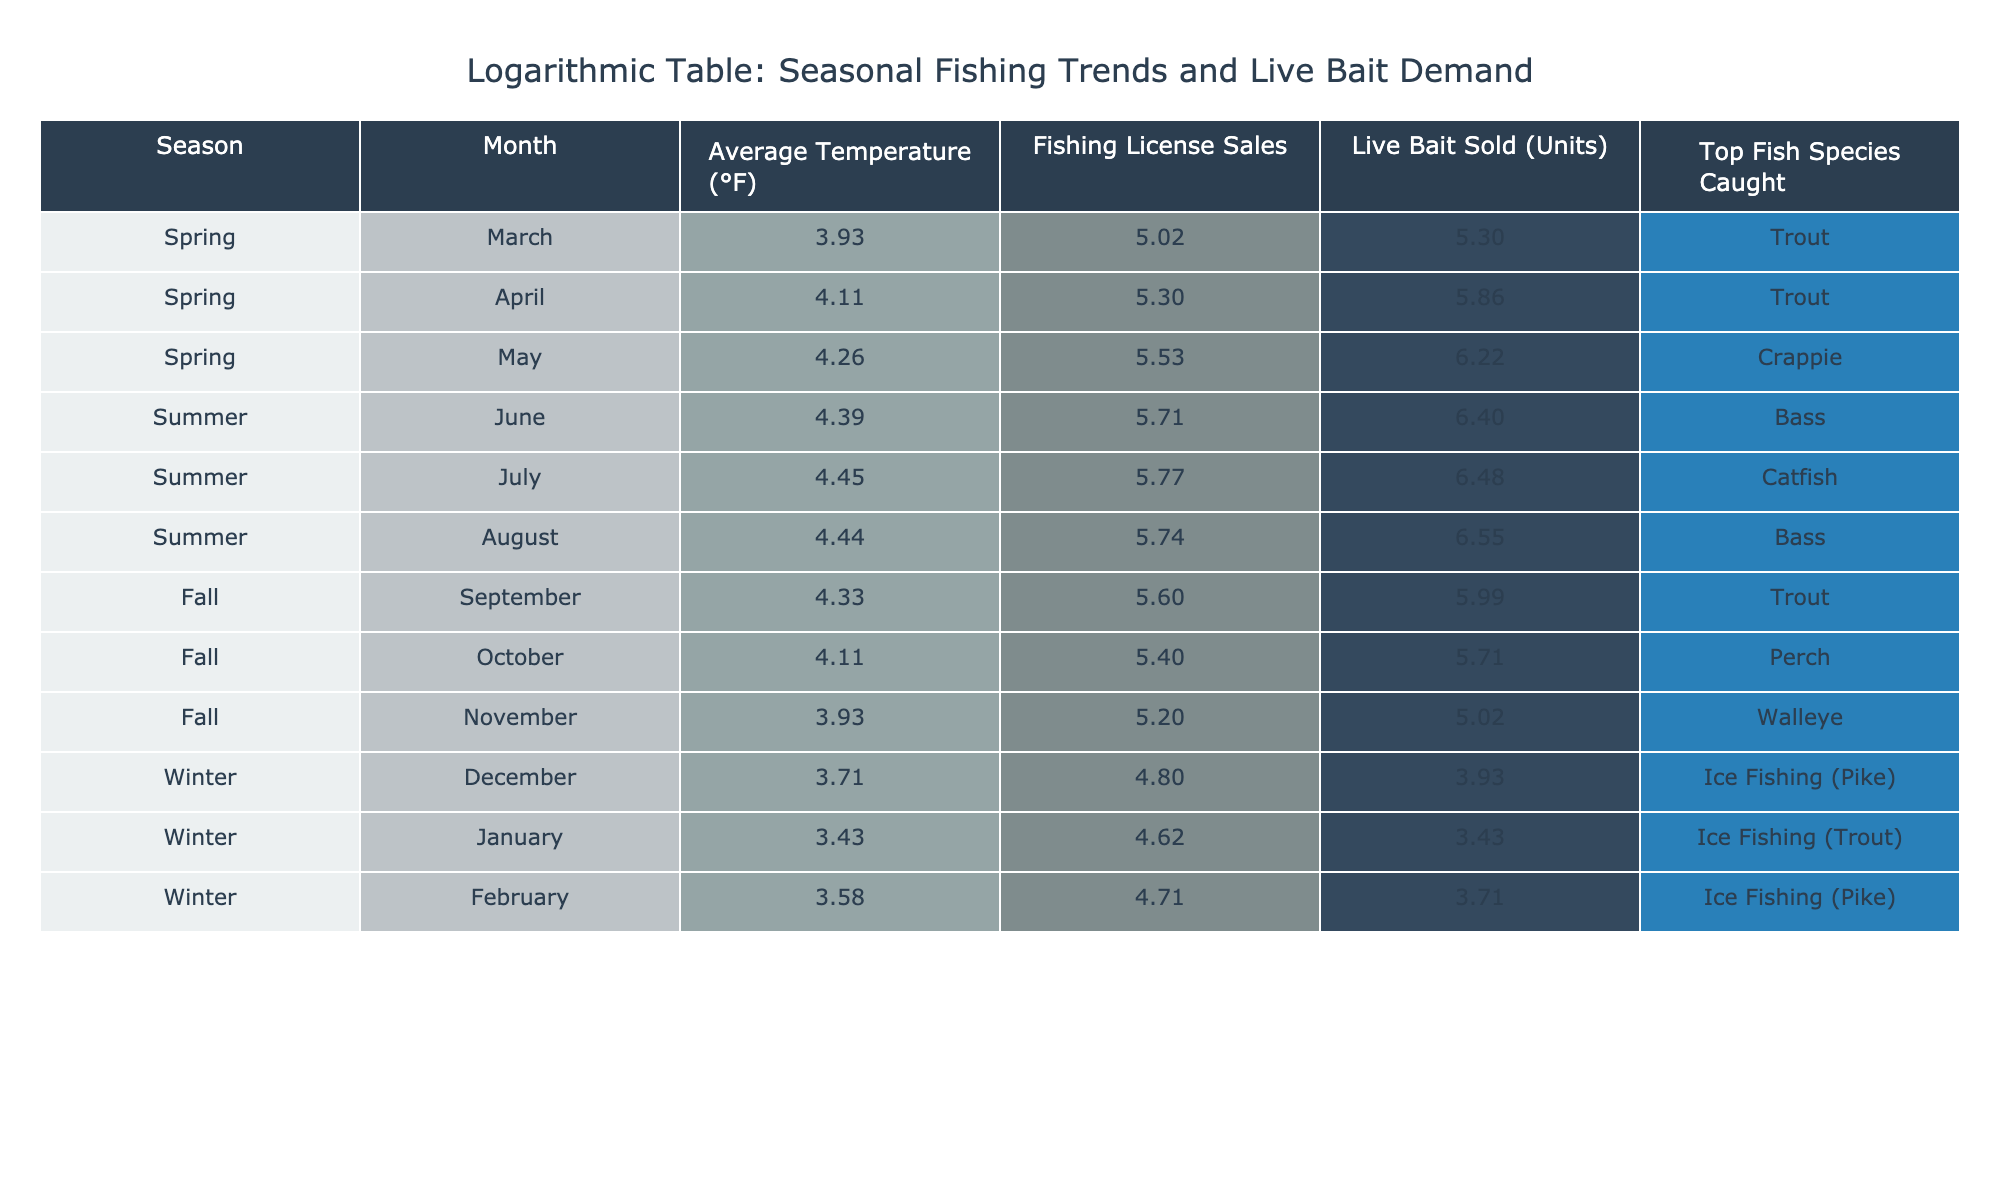What is the average live bait sold in summer? The live bait sold in summer months (June, July, August) are 600, 650, and 700 respectively. We sum these values: 600 + 650 + 700 = 1950. To find the average, we divide by the number of summer months (3): 1950 / 3 = 650.
Answer: 650 Which season has the highest average temperature? Looking at the average temperatures for each season: Spring has 60°F, Summer has 80°F, Fall has 65°F, and Winter has 35°F. The highest value among these is 80°F in Summer.
Answer: Summer Did more fishing licenses get sold in the spring compared to the winter? For Spring, the fishing license sales are March 150, April 200, and May 250, summing to 600. In Winter, the sales are December 120, January 100, and February 110, summing to 330. Since 600 > 330, more licenses were sold in Spring.
Answer: Yes What is the total number of live bait sold in the fall? The live bait sold in the fall months (September, October, November) are 400, 300, and 150 respectively. We sum these values: 400 + 300 + 150 = 850.
Answer: 850 Which top fish species is caught in the highest-selling month for live bait? The month with the highest live bait sold is August with 700 units, and the top fish species caught that month is Bass.
Answer: Bass Is the number of live bait sold consistently higher in summer than in spring? In Spring, the live bait sold are 200, 350, and 500 for March, April, and May respectively, totaling 1050. In Summer, the numbers are 600, 650, and 700, totaling 1950. Since 1950 > 1050, live bait sales are consistently higher in summer.
Answer: Yes How does the fishing license sales compare between October and July? In July, fishing license sales are 320, while October shows 220. Comparing these values, 320 is greater than 220, indicating that more licenses were sold in July.
Answer: More in July What is the difference in average live bait sold between spring and fall? The average live bait sold in Spring (200 + 350 + 500)/3 = 350 and in Fall (400 + 300 + 150)/3 = 300. The difference is 350 - 300 = 50.
Answer: 50 What is the highest recorded number of fishing licenses sold in a single month? The highest sales occur in May with 250 fishing licenses sold.
Answer: 250 